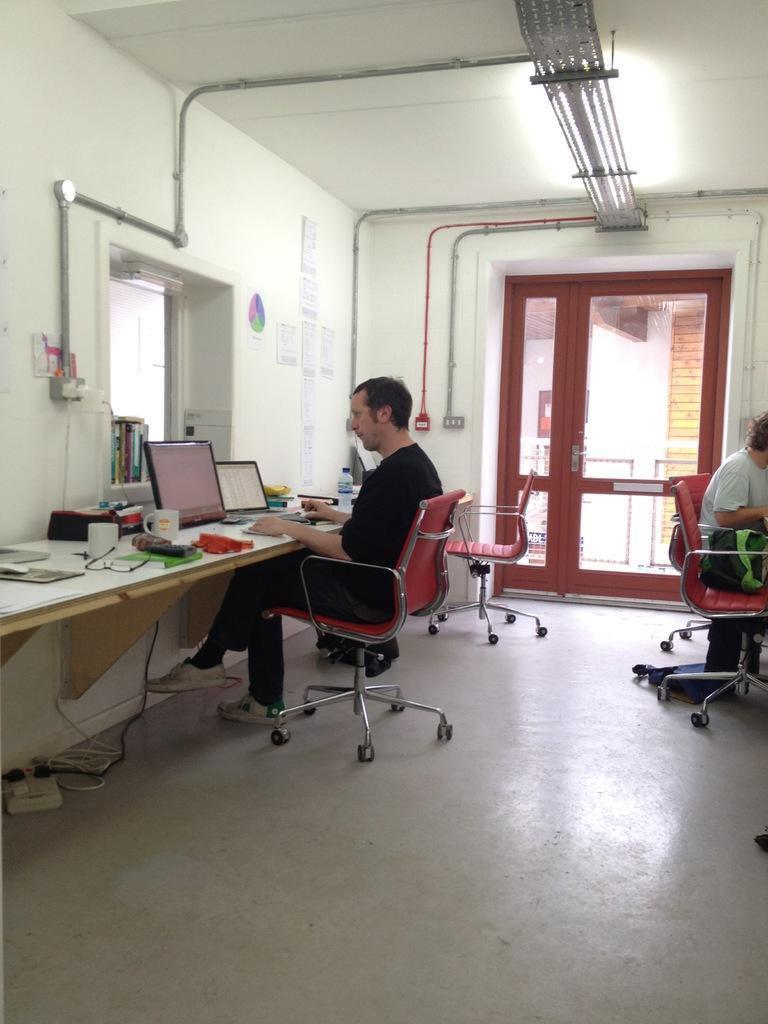In one or two sentences, can you explain what this image depicts? This is a image inside of a room on the left side i can see and on the left side there is a table and there is a person sit on the chair in front of the table. There are the system and coffee cup kept on the table and there is a pipeline connection on the wall and right side i can see a person sit on the chair and there is a door in the middle ,through door i can see a building. 